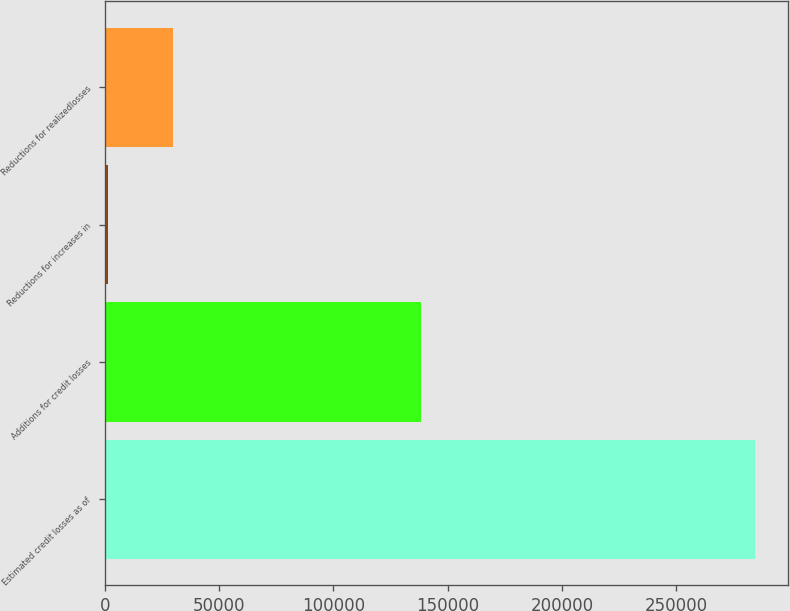<chart> <loc_0><loc_0><loc_500><loc_500><bar_chart><fcel>Estimated credit losses as of<fcel>Additions for credit losses<fcel>Reductions for increases in<fcel>Reductions for realizedlosses<nl><fcel>284513<fcel>138297<fcel>1393<fcel>29705<nl></chart> 